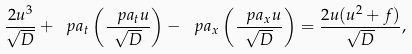Convert formula to latex. <formula><loc_0><loc_0><loc_500><loc_500>\frac { 2 u ^ { 3 } } { \sqrt { D } } + \ p a _ { t } \left ( \frac { \ p a _ { t } u } { \sqrt { D } } \right ) - \ p a _ { x } \left ( \frac { \ p a _ { x } u } { \sqrt { D } } \right ) = \frac { 2 u ( u ^ { 2 } + f ) } { \sqrt { D } } ,</formula> 